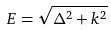<formula> <loc_0><loc_0><loc_500><loc_500>E = \sqrt { \Delta ^ { 2 } + k ^ { 2 } }</formula> 